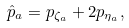Convert formula to latex. <formula><loc_0><loc_0><loc_500><loc_500>\hat { p } _ { a } = p _ { \zeta _ { a } } + 2 p _ { \eta _ { a } } ,</formula> 